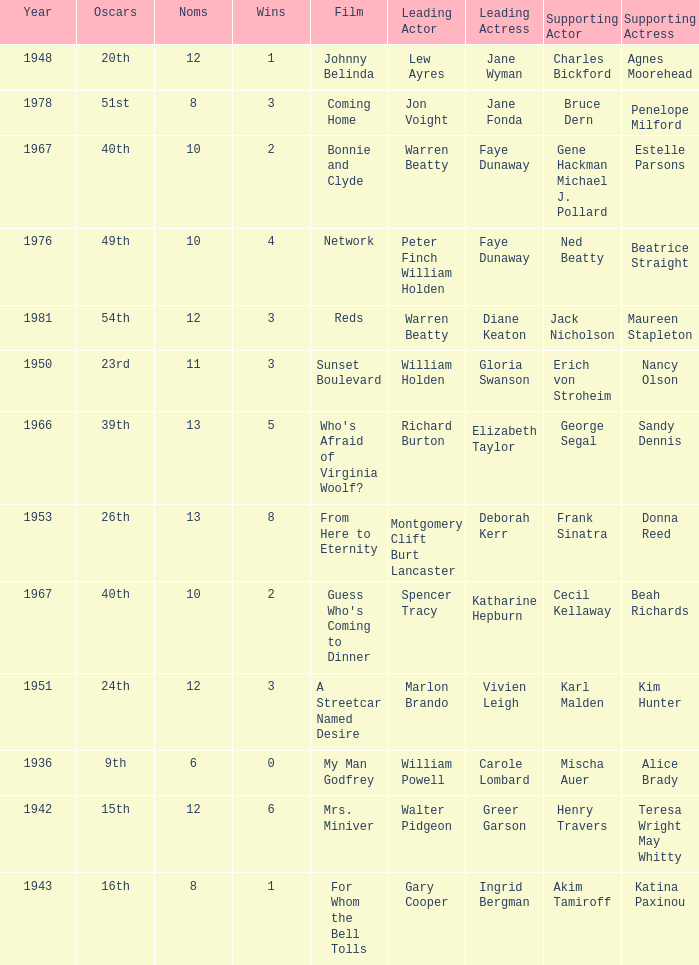Who was the supporting actress in a film with Diane Keaton as the leading actress? Maureen Stapleton. 